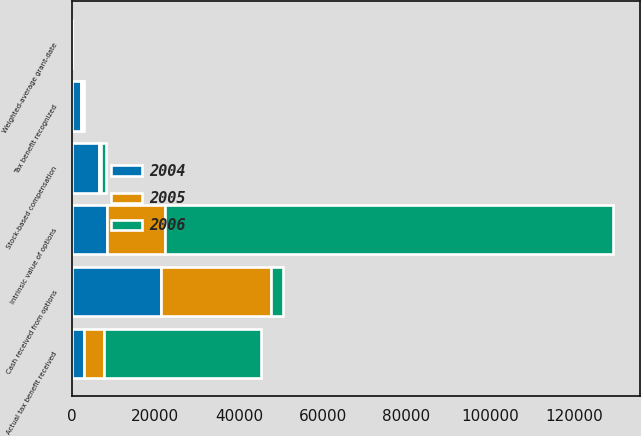Convert chart. <chart><loc_0><loc_0><loc_500><loc_500><stacked_bar_chart><ecel><fcel>Stock-based compensation<fcel>Tax benefit recognized<fcel>Weighted-average grant-date<fcel>Intrinsic value of options<fcel>Cash received from options<fcel>Actual tax benefit received<nl><fcel>2004<fcel>6575<fcel>2301<fcel>11.77<fcel>8394<fcel>21451<fcel>2938<nl><fcel>2006<fcel>977<fcel>342<fcel>9.31<fcel>107104<fcel>2938<fcel>37486<nl><fcel>2005<fcel>543<fcel>190<fcel>11.83<fcel>13841<fcel>26118<fcel>4844<nl></chart> 